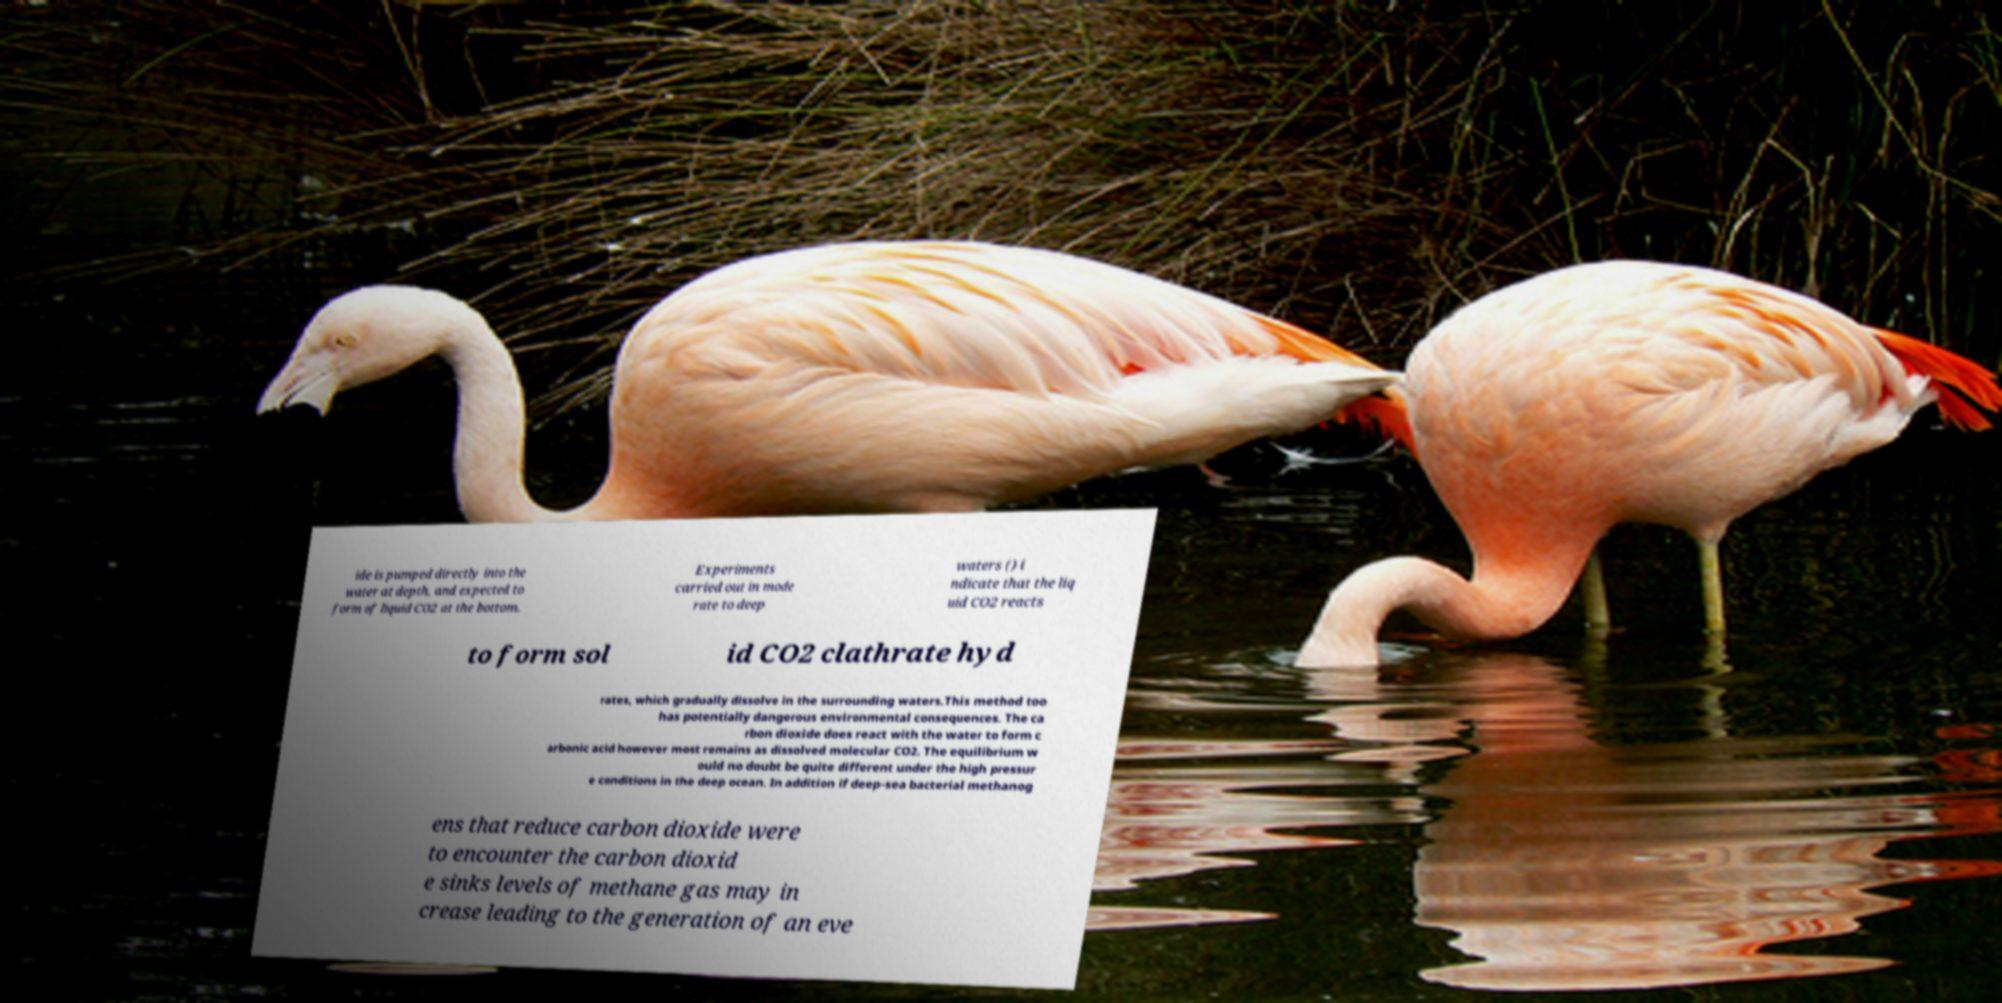There's text embedded in this image that I need extracted. Can you transcribe it verbatim? ide is pumped directly into the water at depth, and expected to form of liquid CO2 at the bottom. Experiments carried out in mode rate to deep waters () i ndicate that the liq uid CO2 reacts to form sol id CO2 clathrate hyd rates, which gradually dissolve in the surrounding waters.This method too has potentially dangerous environmental consequences. The ca rbon dioxide does react with the water to form c arbonic acid however most remains as dissolved molecular CO2. The equilibrium w ould no doubt be quite different under the high pressur e conditions in the deep ocean. In addition if deep-sea bacterial methanog ens that reduce carbon dioxide were to encounter the carbon dioxid e sinks levels of methane gas may in crease leading to the generation of an eve 